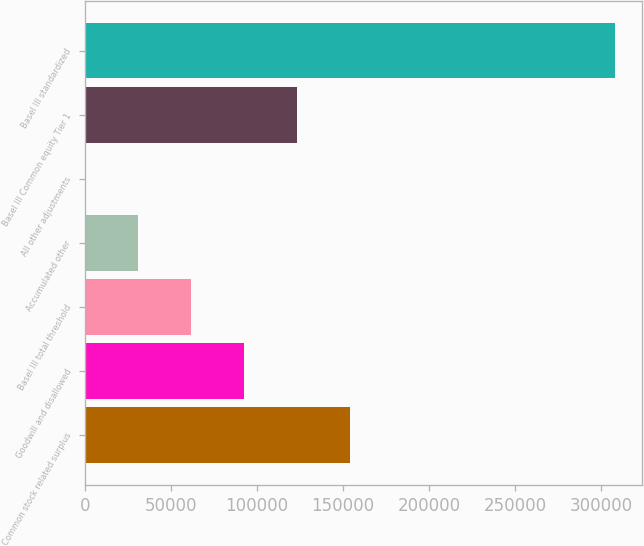Convert chart. <chart><loc_0><loc_0><loc_500><loc_500><bar_chart><fcel>Common stock related surplus<fcel>Goodwill and disallowed<fcel>Basel III total threshold<fcel>Accumulated other<fcel>All other adjustments<fcel>Basel III Common equity Tier 1<fcel>Basel III standardized<nl><fcel>154369<fcel>92709.8<fcel>61880.2<fcel>31050.6<fcel>221<fcel>123539<fcel>308517<nl></chart> 